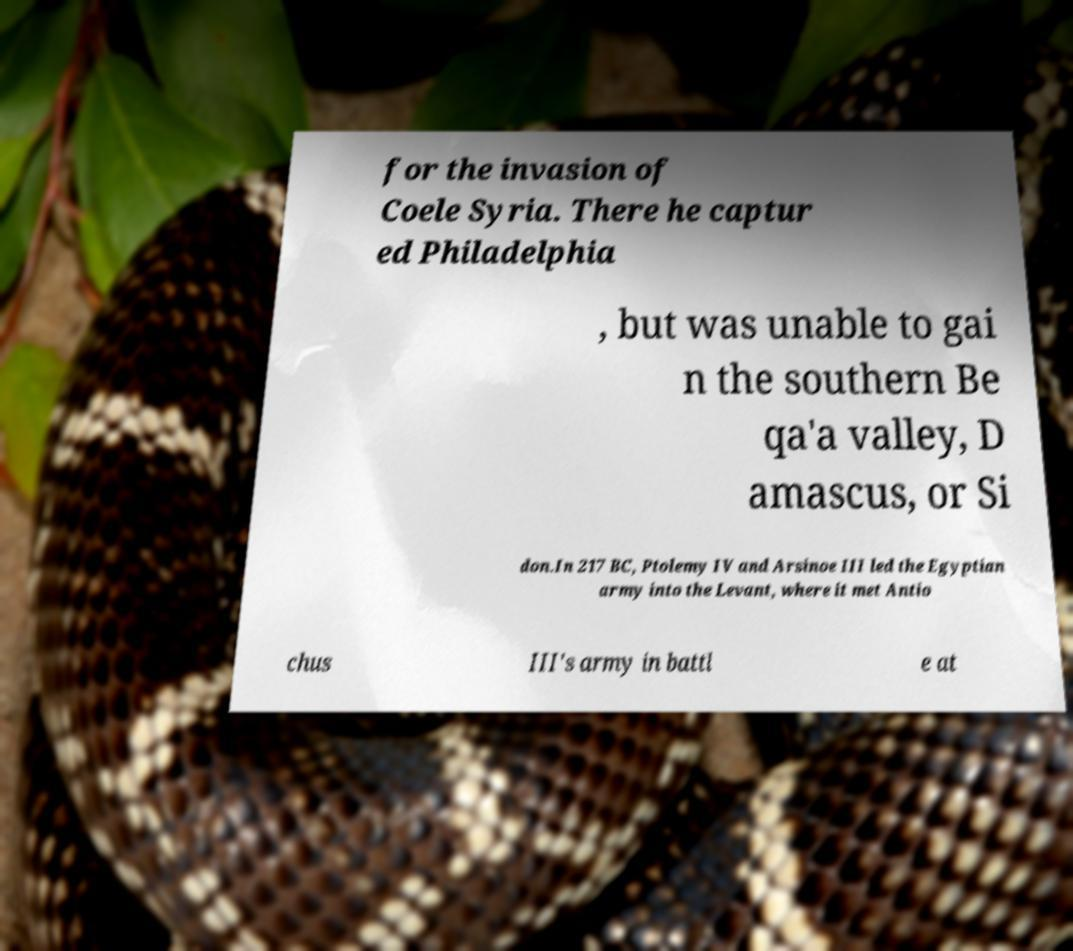I need the written content from this picture converted into text. Can you do that? for the invasion of Coele Syria. There he captur ed Philadelphia , but was unable to gai n the southern Be qa'a valley, D amascus, or Si don.In 217 BC, Ptolemy IV and Arsinoe III led the Egyptian army into the Levant, where it met Antio chus III's army in battl e at 